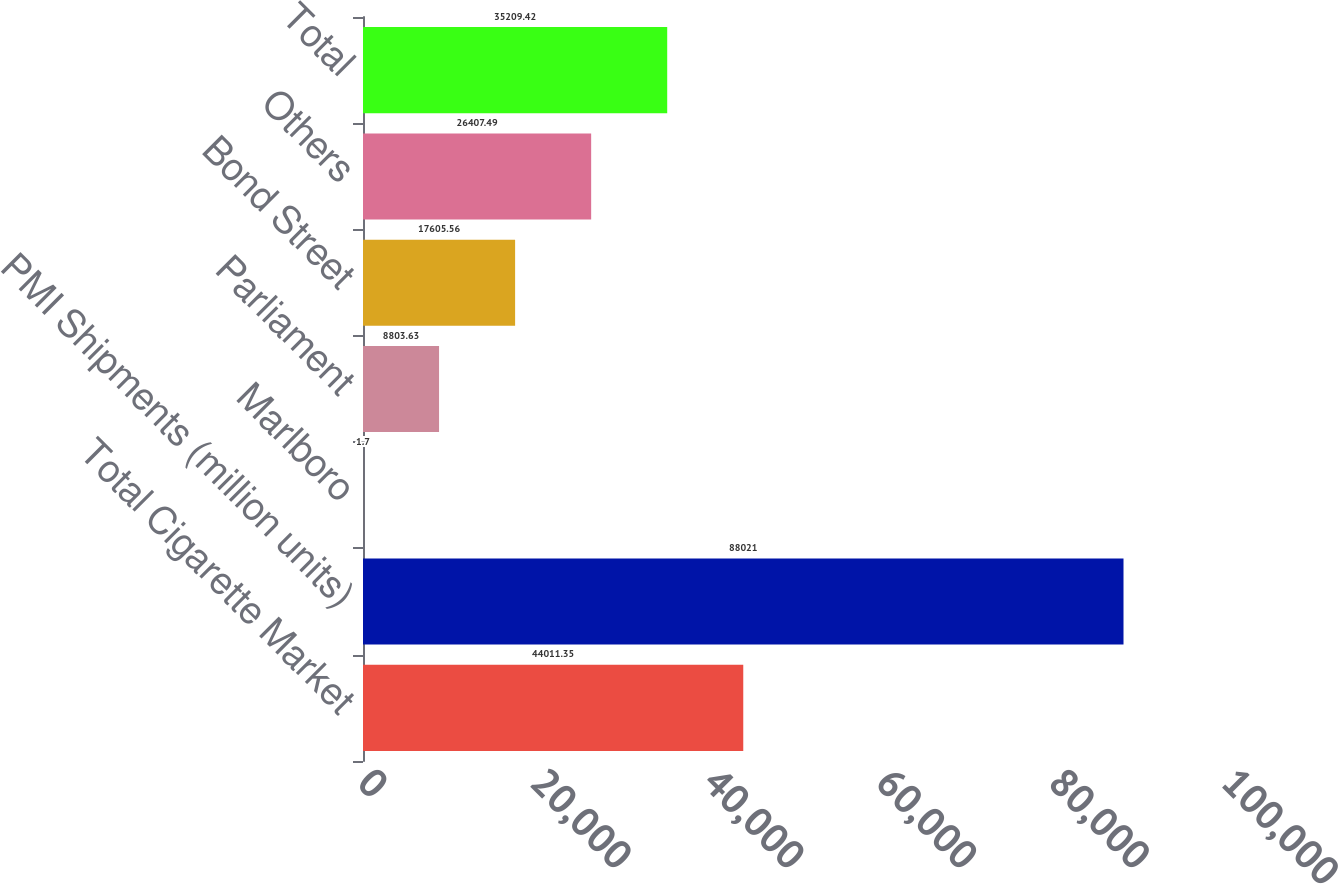Convert chart to OTSL. <chart><loc_0><loc_0><loc_500><loc_500><bar_chart><fcel>Total Cigarette Market<fcel>PMI Shipments (million units)<fcel>Marlboro<fcel>Parliament<fcel>Bond Street<fcel>Others<fcel>Total<nl><fcel>44011.3<fcel>88021<fcel>1.7<fcel>8803.63<fcel>17605.6<fcel>26407.5<fcel>35209.4<nl></chart> 